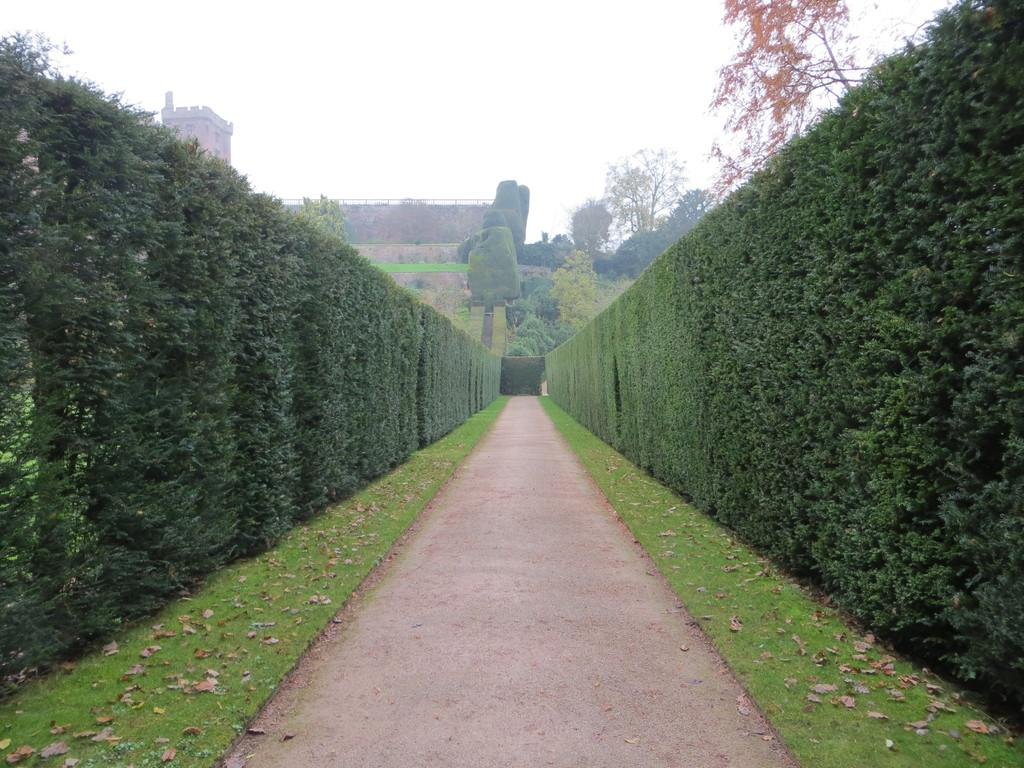What type of vegetation can be seen in the image? There are bushes and grass with dry leaves in the image. Is there any indication of a path or walkway in the image? Yes, there is a path visible in the image. What can be seen in the background of the image? There are trees, a fort, and the sky visible in the background of the image. What type of quince is being sold at the store in the image? There is no store or quince present in the image. What type of treatment is being administered to the trees in the image? There is no treatment being administered to the trees in the image; they appear to be in their natural state. 